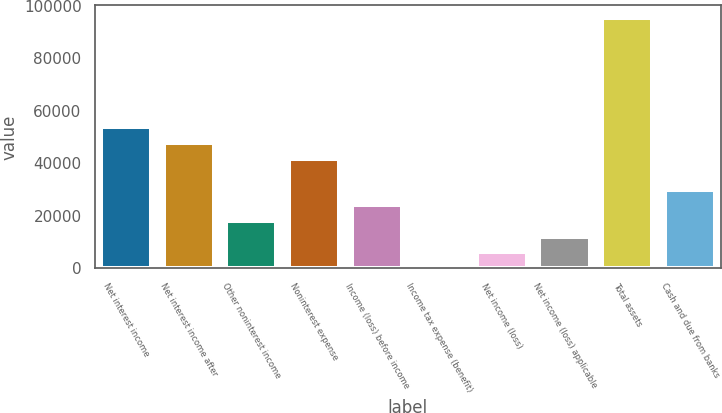Convert chart. <chart><loc_0><loc_0><loc_500><loc_500><bar_chart><fcel>Net interest income<fcel>Net interest income after<fcel>Other noninterest income<fcel>Noninterest expense<fcel>Income (loss) before income<fcel>Income tax expense (benefit)<fcel>Net income (loss)<fcel>Net income (loss) applicable<fcel>Total assets<fcel>Cash and due from banks<nl><fcel>53717.2<fcel>47764.5<fcel>18000.7<fcel>41811.7<fcel>23953.4<fcel>142.4<fcel>6095.16<fcel>12047.9<fcel>95386.6<fcel>29906.2<nl></chart> 